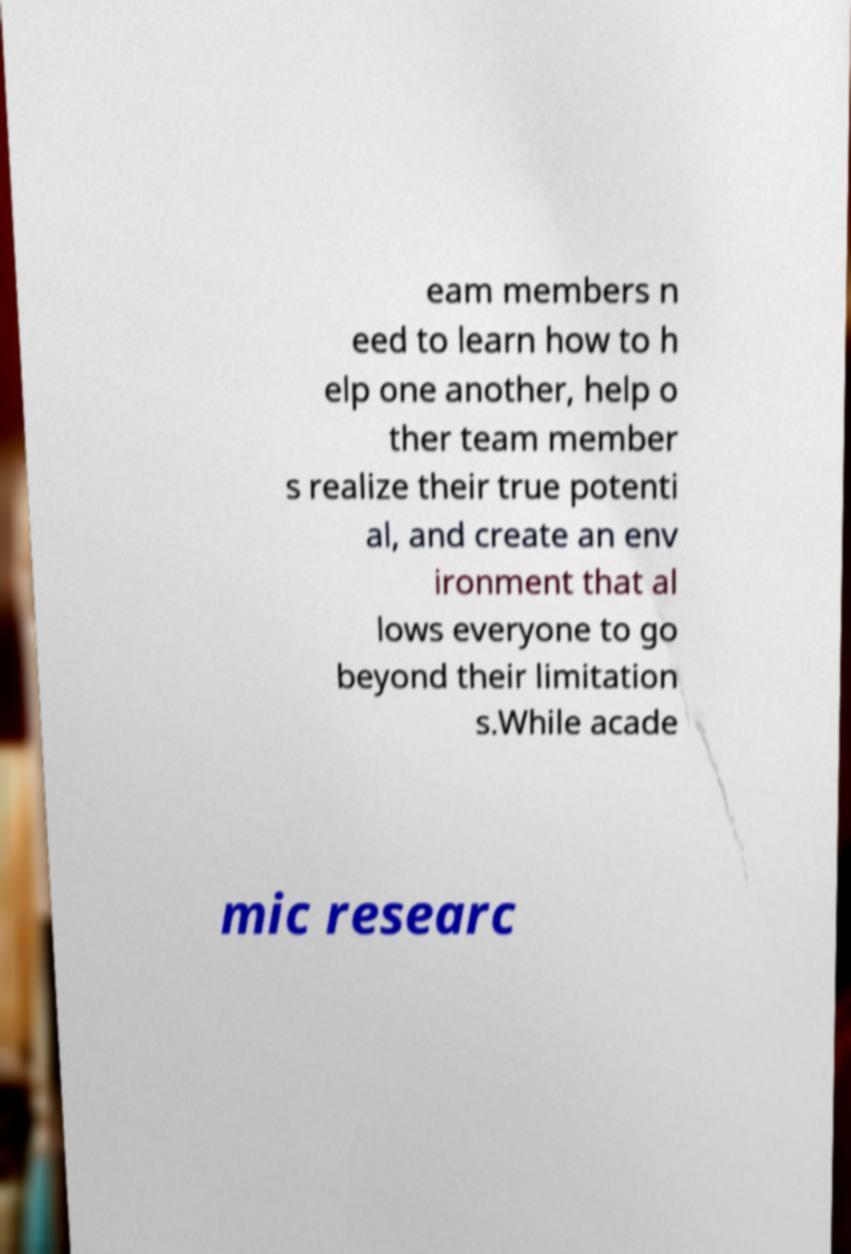Please identify and transcribe the text found in this image. eam members n eed to learn how to h elp one another, help o ther team member s realize their true potenti al, and create an env ironment that al lows everyone to go beyond their limitation s.While acade mic researc 